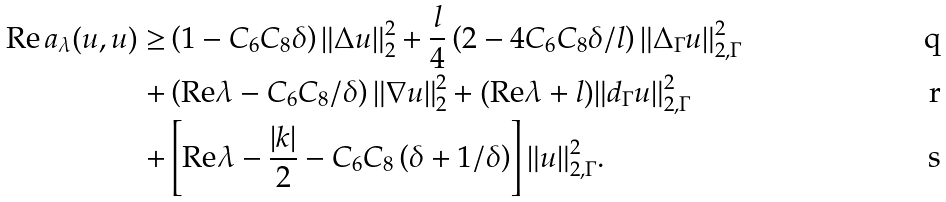<formula> <loc_0><loc_0><loc_500><loc_500>\text {Re} \, a _ { \lambda } ( u , u ) \geq & \left ( 1 - C _ { 6 } C _ { 8 } \delta \right ) \| \Delta u \| _ { 2 } ^ { 2 } + \frac { l } { 4 } \left ( 2 - 4 C _ { 6 } C _ { 8 } \delta / l \right ) \| \Delta _ { \Gamma } u \| _ { 2 , \Gamma } ^ { 2 } \\ + & \left ( \text {Re} \lambda - C _ { 6 } C _ { 8 } / \delta \right ) \| \nabla u \| _ { 2 } ^ { 2 } + ( \text {Re} \lambda + l ) \| d _ { \Gamma } u \| _ { 2 , \Gamma } ^ { 2 } \\ + & \left [ \text {Re} \lambda - \frac { | k | } 2 - C _ { 6 } C _ { 8 } \left ( \delta + 1 / \delta \right ) \right ] \| u \| _ { 2 , \Gamma } ^ { 2 } .</formula> 